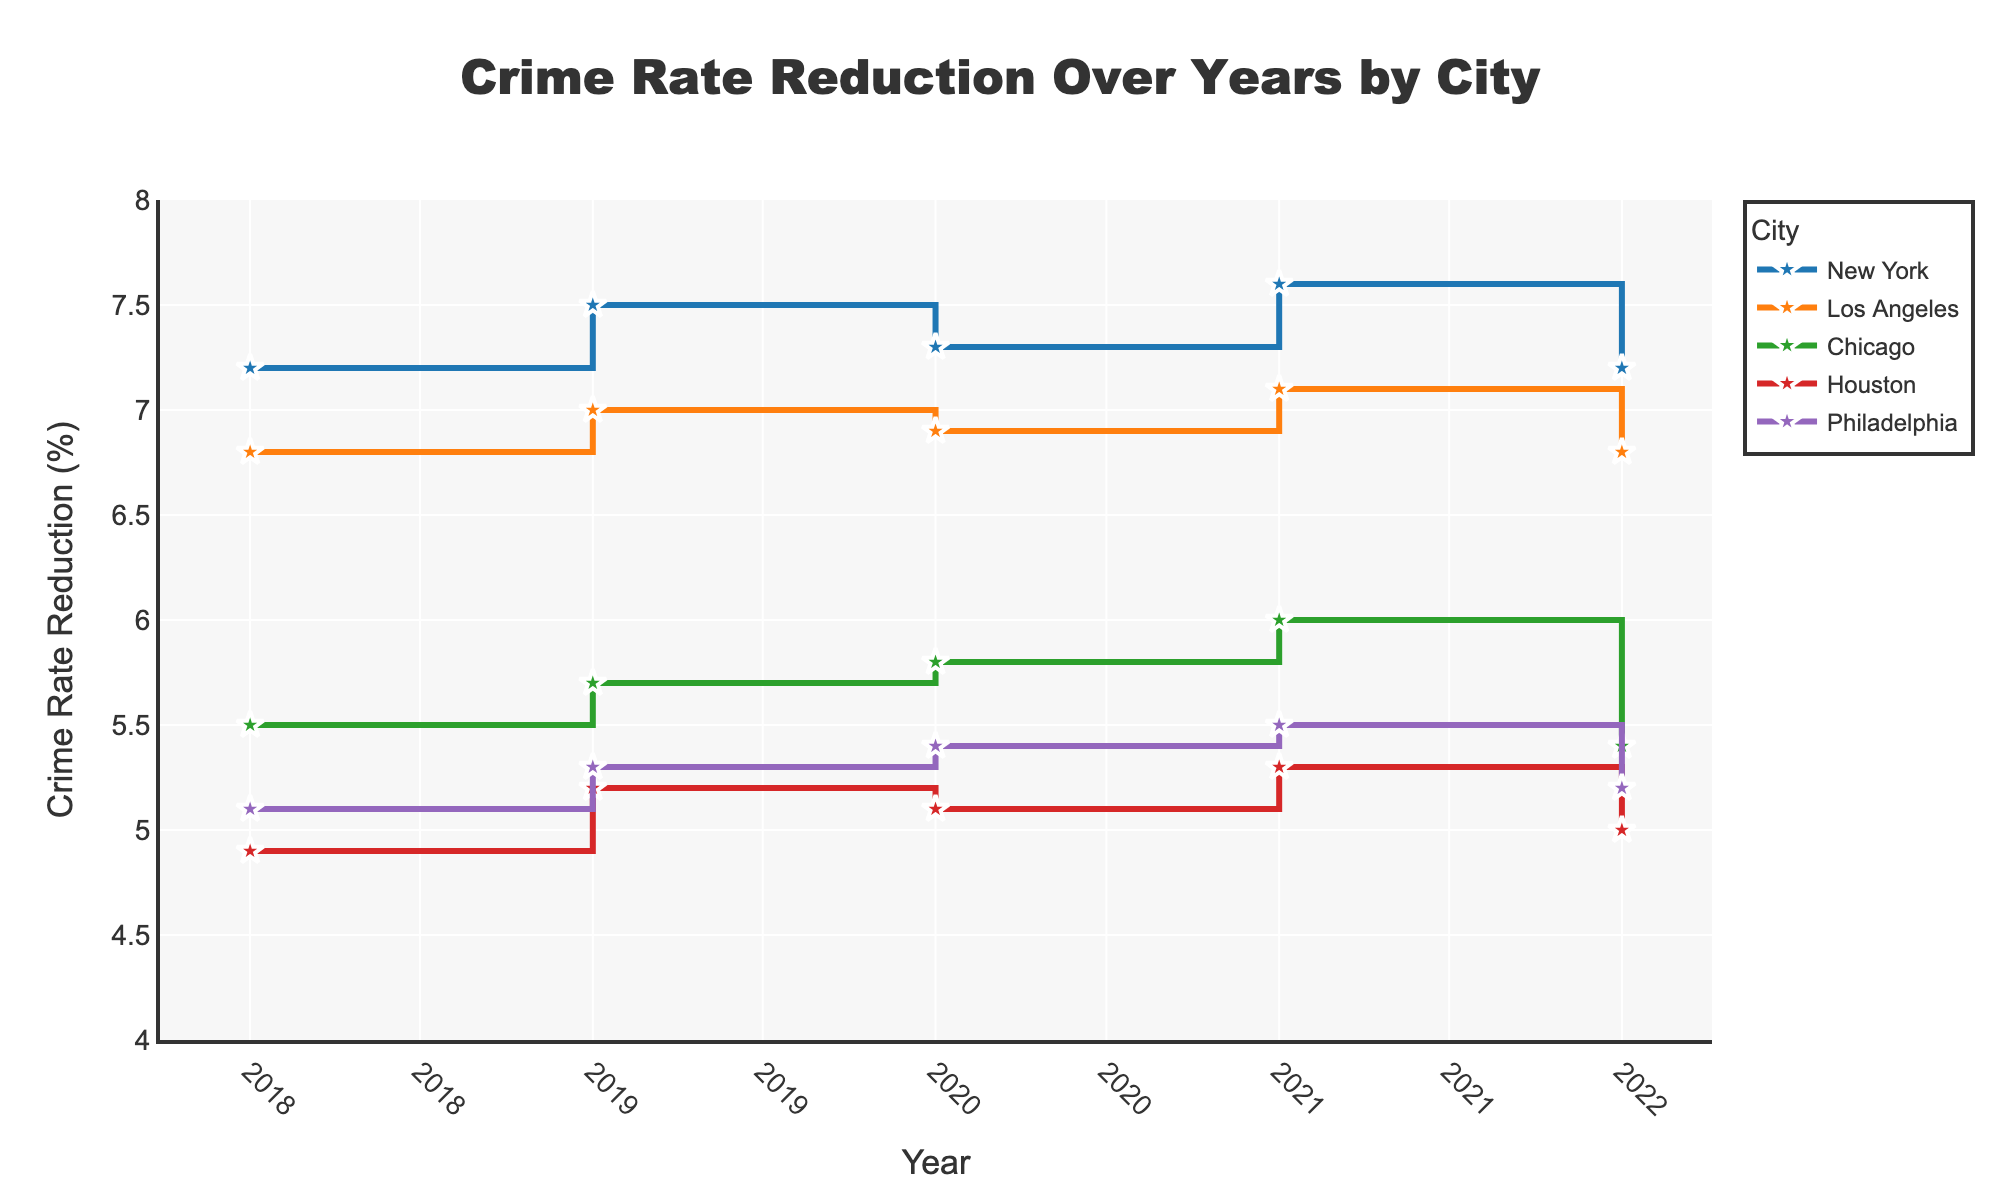What is the title of the figure? The title is typically located at the top of the figure. In this case, the title is "Crime Rate Reduction Over Years by City".
Answer: Crime Rate Reduction Over Years by City What are the cities included in the plot? The cities are represented by different colored lines in the plot. By checking the legend, you can see the cities are New York, Los Angeles, Chicago, Houston, and Philadelphia.
Answer: New York, Los Angeles, Chicago, Houston, Philadelphia What is the y-axis label? The y-axis label on the left side of the plot indicates the type of data plotted along this axis. Here, it is labeled "Crime Rate Reduction (%)".
Answer: Crime Rate Reduction (%) Which city had the highest crime rate reduction in 2021? To find this, look at the points corresponding to 2021 on the x-axis for each city. New York has the highest value at that point, which is 7.6%.
Answer: New York What is the trend in crime rate reduction for Philadelphia over the years? Follow the line corresponding to Philadelphia, marked with a specific color, from 2018 to 2022. The crime rate reduction shows a slight but consistent increase from 5.1% in 2018 to 5.5% in 2021, then a slight decrease to 5.2% in 2022.
Answer: Slight increase then slight decrease On average, how did crime rate reduction change over the years for Los Angeles? To find the average change, look at the values for Los Angeles in each year: 2018 (6.8%), 2019 (7.0%), 2020 (6.9%), 2021 (7.1%), and 2022 (6.8%). Calculate the total change and then divide by the number of years.
Answer: (6.8 + 7.0 + 6.9 + 7.1 + 6.8) / 5 = 6.92% Between 2019 and 2020, did any city show a decrease in crime rate reduction? Compare the crime rate reduction values for 2019 and 2020 for each city. Los Angeles, Houston, and Philadelphia show a decrease between these years.
Answer: Los Angeles, Houston, Philadelphia What is the shape of the lines on the plot, and what does this represent? The lines take on a "steps" or "stair" shape due to the 'hv' line shape used. This represents the change occurring at the start of each year rather than a smooth transition.
Answer: Steps or stair Which city showed the most significant improvement in crime rate reduction from 2018 to 2021? Calculate the difference between 2018 and 2021 values for each city. New York improved from 7.2% to 7.6% (0.4%), Los Angeles from 6.8% to 7.1% (0.3%), Chicago from 5.5% to 6.0% (0.5%), Houston from 4.9% to 5.3% (0.4%), and Philadelphia from 5.1% to 5.5% (0.4%). The most significant numerical improvement is seen in Chicago.
Answer: Chicago 